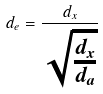Convert formula to latex. <formula><loc_0><loc_0><loc_500><loc_500>d _ { e } = \frac { d _ { x } } { \sqrt { \frac { d _ { x } } { d _ { a } } } }</formula> 